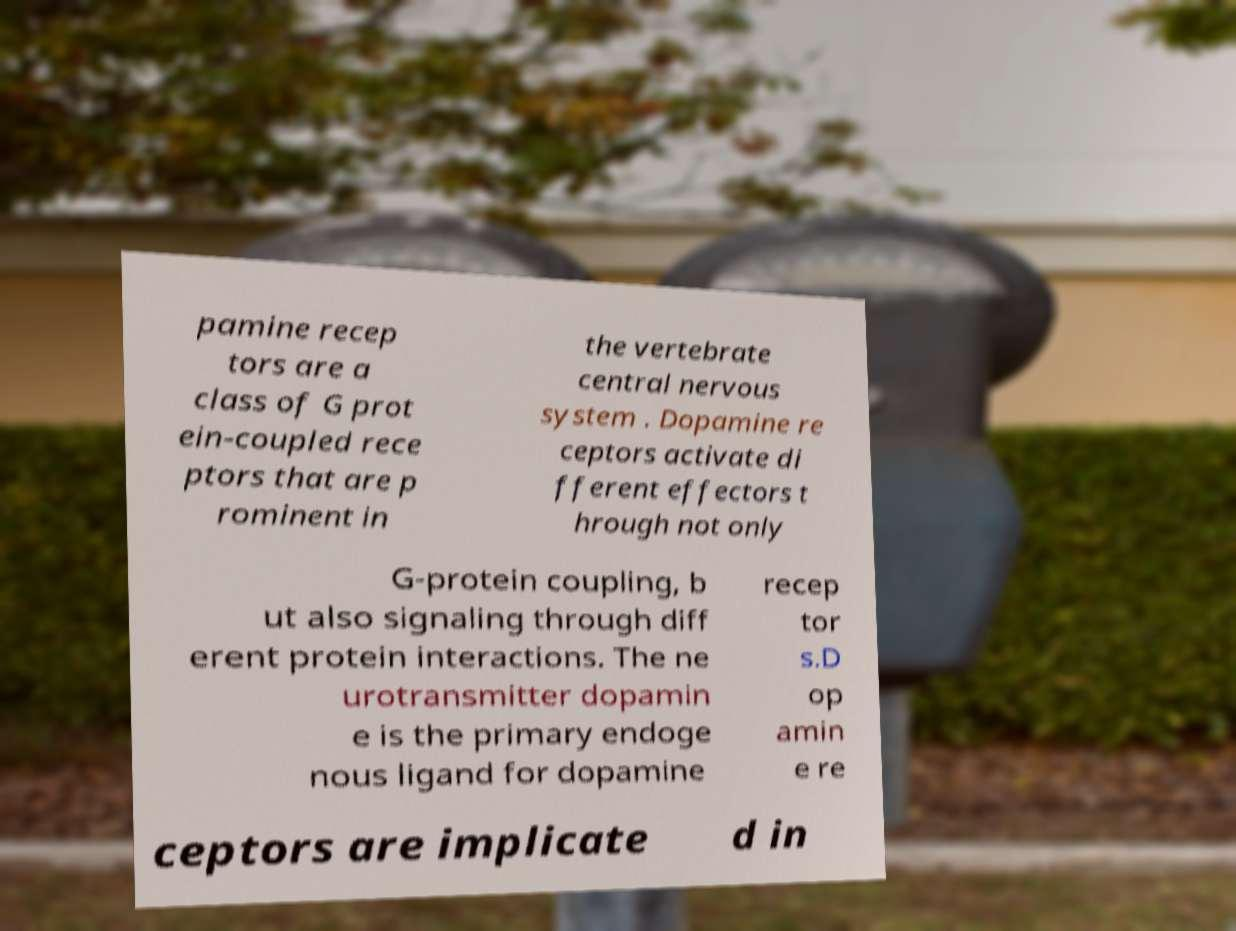There's text embedded in this image that I need extracted. Can you transcribe it verbatim? pamine recep tors are a class of G prot ein-coupled rece ptors that are p rominent in the vertebrate central nervous system . Dopamine re ceptors activate di fferent effectors t hrough not only G-protein coupling, b ut also signaling through diff erent protein interactions. The ne urotransmitter dopamin e is the primary endoge nous ligand for dopamine recep tor s.D op amin e re ceptors are implicate d in 